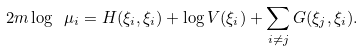<formula> <loc_0><loc_0><loc_500><loc_500>2 m \log \ \mu _ { i } = H ( \xi _ { i } , \xi _ { i } ) + \log V ( \xi _ { i } ) + \sum _ { i \neq j } G ( \xi _ { j } , \xi _ { i } ) .</formula> 